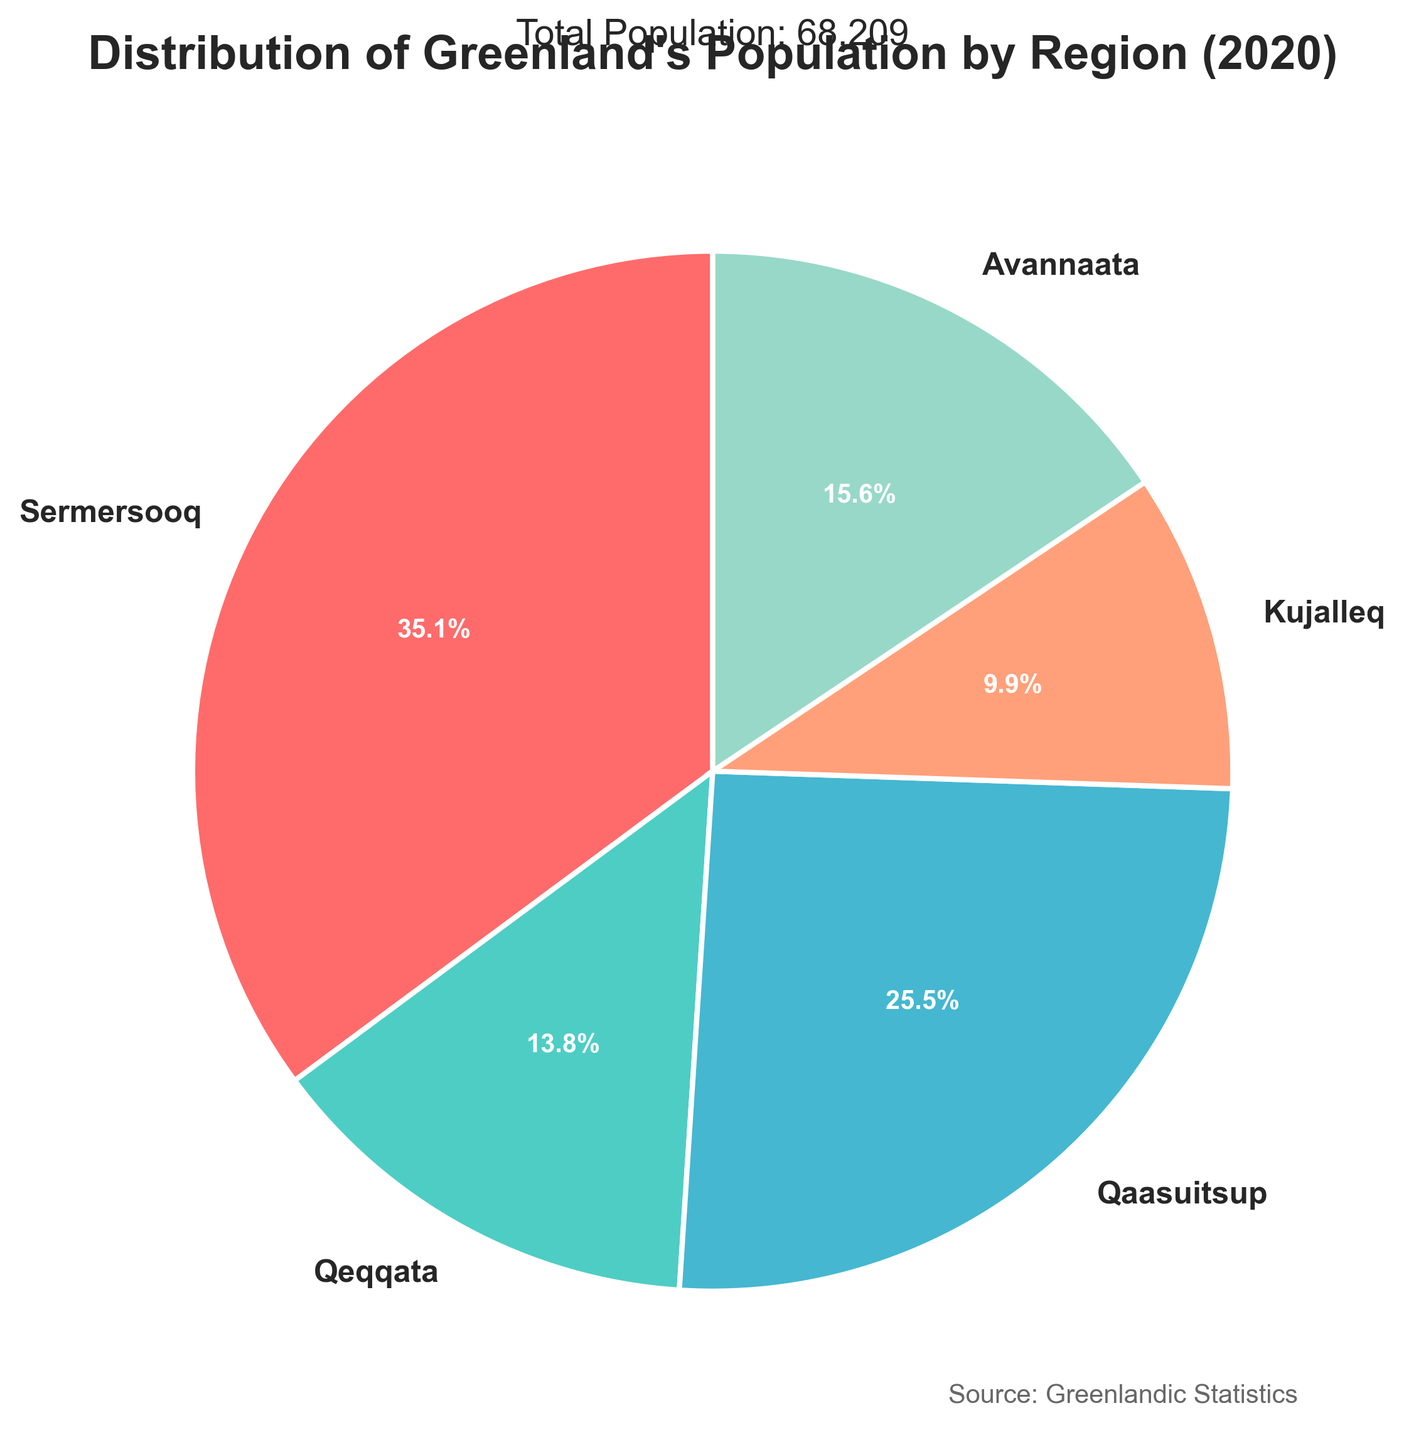Which region in Greenland had the highest population in 2020? The pie chart clearly shows the distribution of population by region, and the region with the largest pie wedge is Sermersooq.
Answer: Sermersooq What percentage of the total population lived in Kujalleq in 2020? Refer to the pie chart where the percentage labels are directly visible. The wedge for Kujalleq shows 12.6%.
Answer: 12.6% How does the population of Avannaata compare to Qeqqata? The pie chart shows that Avannaata has a larger wedge compared to Qeqqata, indicating a higher percentage of the total population.
Answer: Avannaata has a higher population than Qeqqata What is the combined population percentage for Qeqqata and Kujalleq? Qeqqata and Kujalleq have percentages of 17.5% and 12.6%, respectively. Summing these numbers gives 17.5% + 12.6% = 30.1%.
Answer: 30.1% If you combine the populations of Qeqqata and Avannaata, is it more or less than the population of Sermersooq? The pie chart shows Qeqqata at 17.5% and Avannaata at 19.8%. Combined, they form 37.3%. Sermersooq is at 44.9%, so it's less than Sermersooq.
Answer: Less Which region has the smallest population in 2020 and what is its percentage of the total population? Based on the pie chart, Kujalleq has the smallest wedge among the regions, and the percentage is 12.6%.
Answer: Kujalleq, 12.6% What is the visual distinction between the regions with the highest and lowest population? The region with the highest population, Sermersooq, has the largest pie wedge, displayed in red. The region with the lowest population, Kujalleq, has the smallest wedge, displayed in light orange.
Answer: Sermersooq's wedge is largest and red; Kujalleq's wedge is smallest and light orange Is the population of Qaasuitsup greater than the combined populations of Qeqqata and Kujalleq? Qaasuitsup has 32.6% of the total population. Qeqqata and Kujalleq combined have 30.1%. Therefore, Qaasuitsup's population is greater.
Answer: Yes What region represents approximately one-fifth of the total population? The pie chart shows that Avannaata has 19.8%, which is close to one-fifth (20%).
Answer: Avannaata 